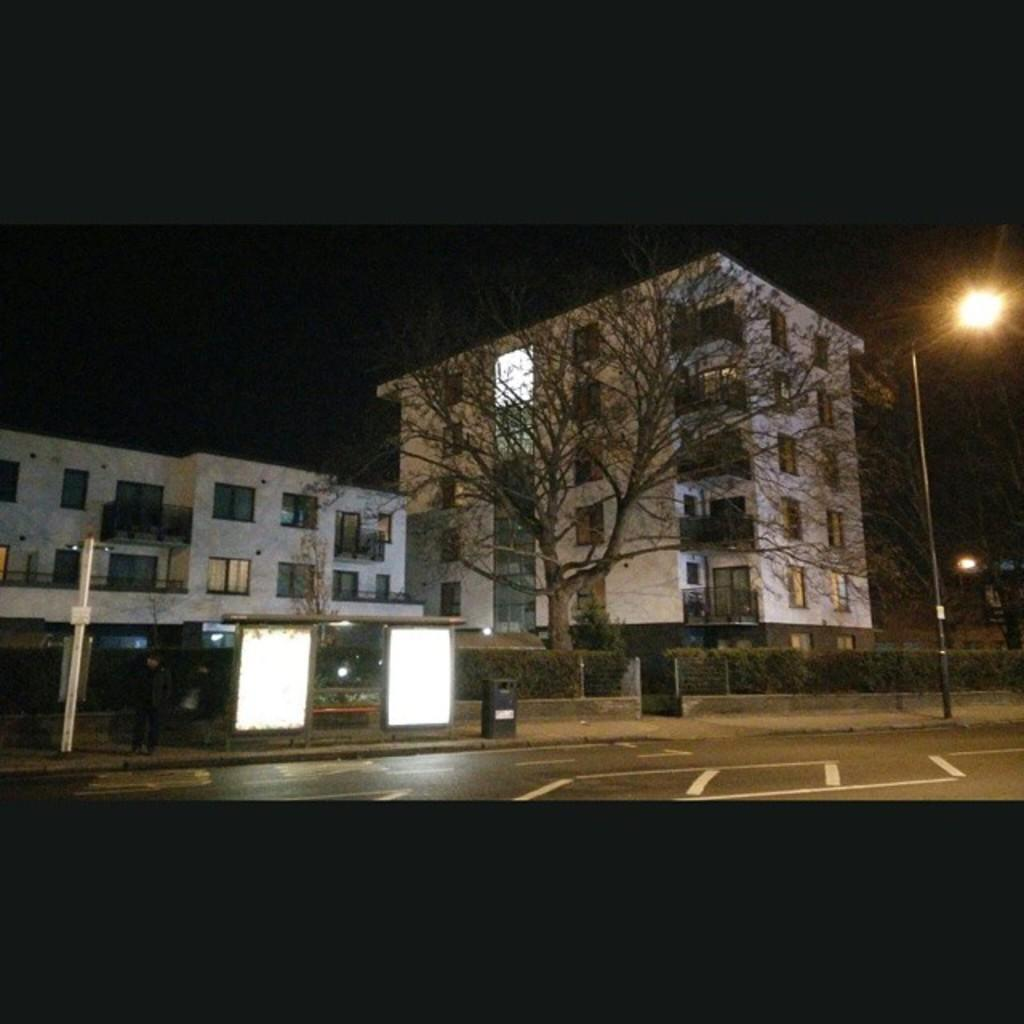What type of structures can be seen in the image? There are buildings in the image. What natural elements are present in the image? There are trees and plants in the image. What man-made objects can be seen in the image? There are boards, poles, and lights in the image. Is there any human presence in the image? Yes, there is a person in the image. What is the condition of the sky in the image? The sky is dark in the image. What type of pathway is visible in the image? There is a road in the image. Can you describe any other objects present in the image? There are other objects in the image, but their specific details are not mentioned in the provided facts. How many bulbs are attached to the person in the image? There is no mention of bulbs or any attachment to the person in the image. What type of horses can be seen grazing on the plants in the image? There are no horses present in the image; it features buildings, trees, plants, boards, poles, lights, a person, a dark sky, and a road. 